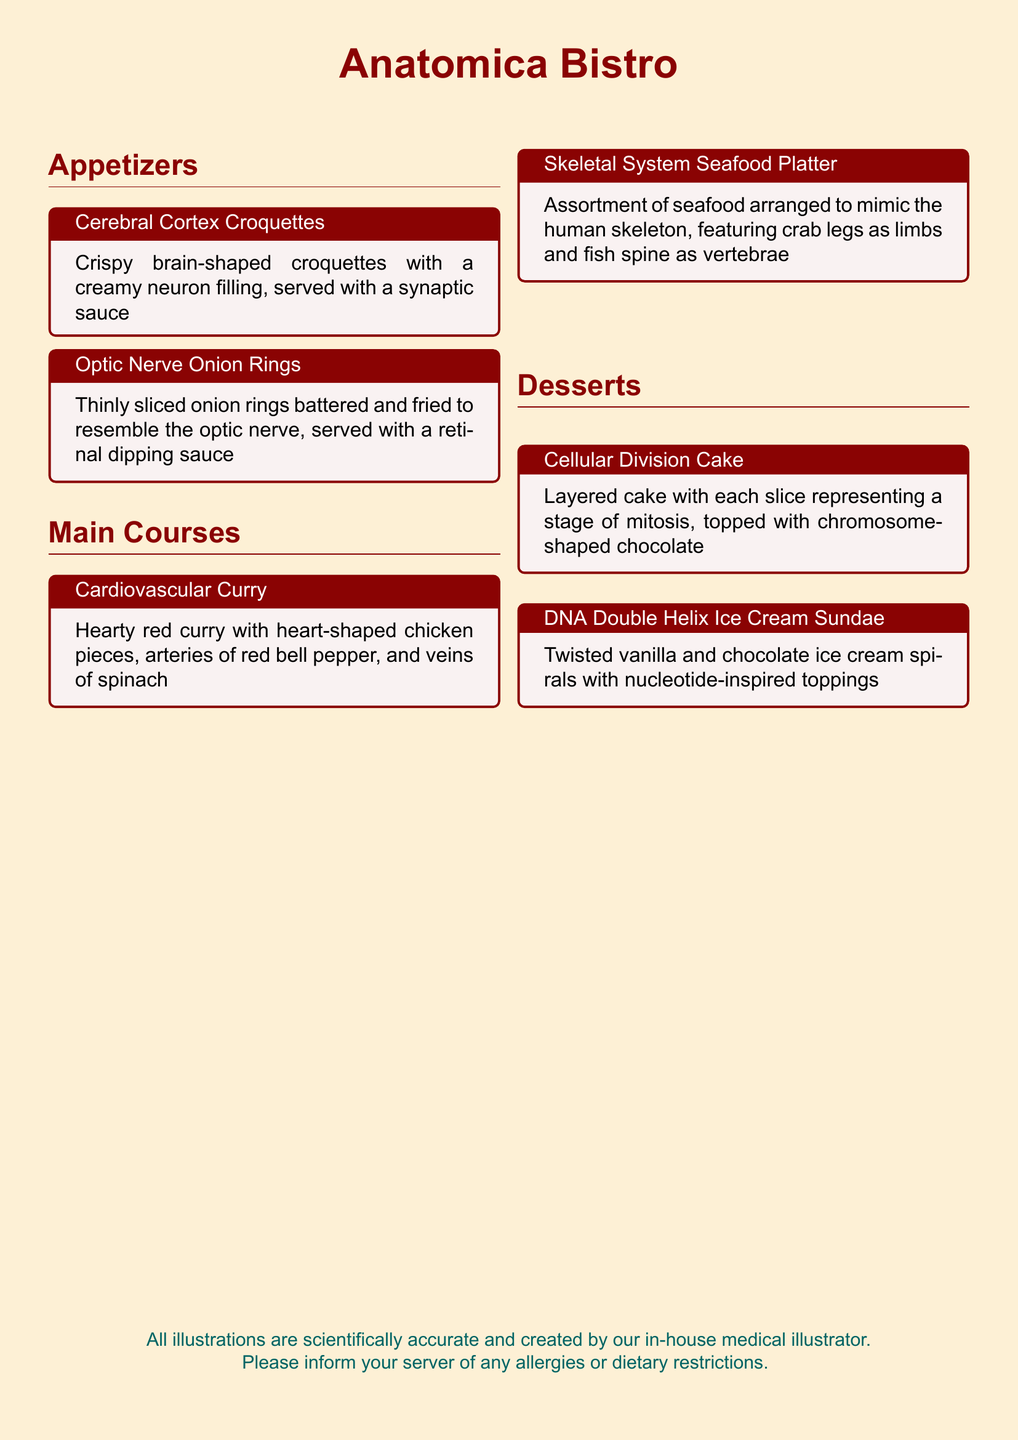What is the name of the restaurant? The restaurant's name appears at the top of the menu in large text.
Answer: Anatomica Bistro How many appetizers are listed? The menu section for appetizers contains two different items.
Answer: 2 What dish features heart-shaped chicken pieces? The name of the main course that includes heart-shaped chicken is written in a tcolorbox.
Answer: Cardiovascular Curry What is the topping on the Cellular Division Cake? The cake is topped with a specific type of chocolate that resembles chromosomes.
Answer: Chromosome-shaped chocolate What is the theme of the desserts? The desserts are named and designed based on a specific scientific concept related to biology.
Answer: Cellular processes 